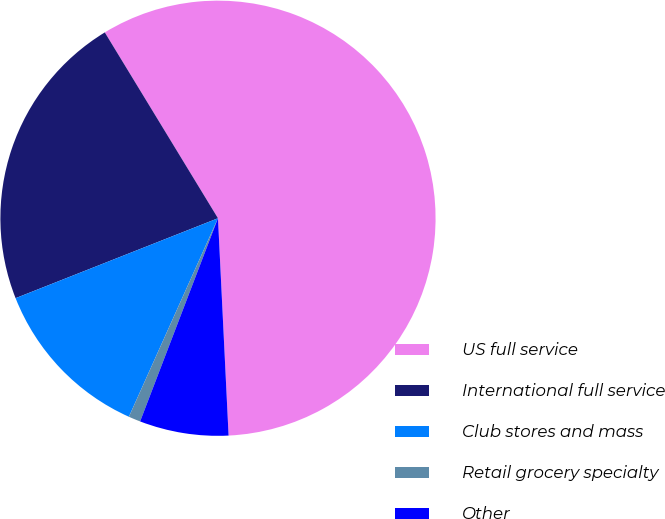Convert chart to OTSL. <chart><loc_0><loc_0><loc_500><loc_500><pie_chart><fcel>US full service<fcel>International full service<fcel>Club stores and mass<fcel>Retail grocery specialty<fcel>Other<nl><fcel>57.93%<fcel>22.28%<fcel>12.3%<fcel>0.89%<fcel>6.6%<nl></chart> 